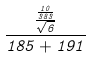<formula> <loc_0><loc_0><loc_500><loc_500>\frac { \frac { \frac { 1 0 } { 3 8 3 } } { \sqrt { 6 } } } { 1 8 5 + 1 9 1 }</formula> 